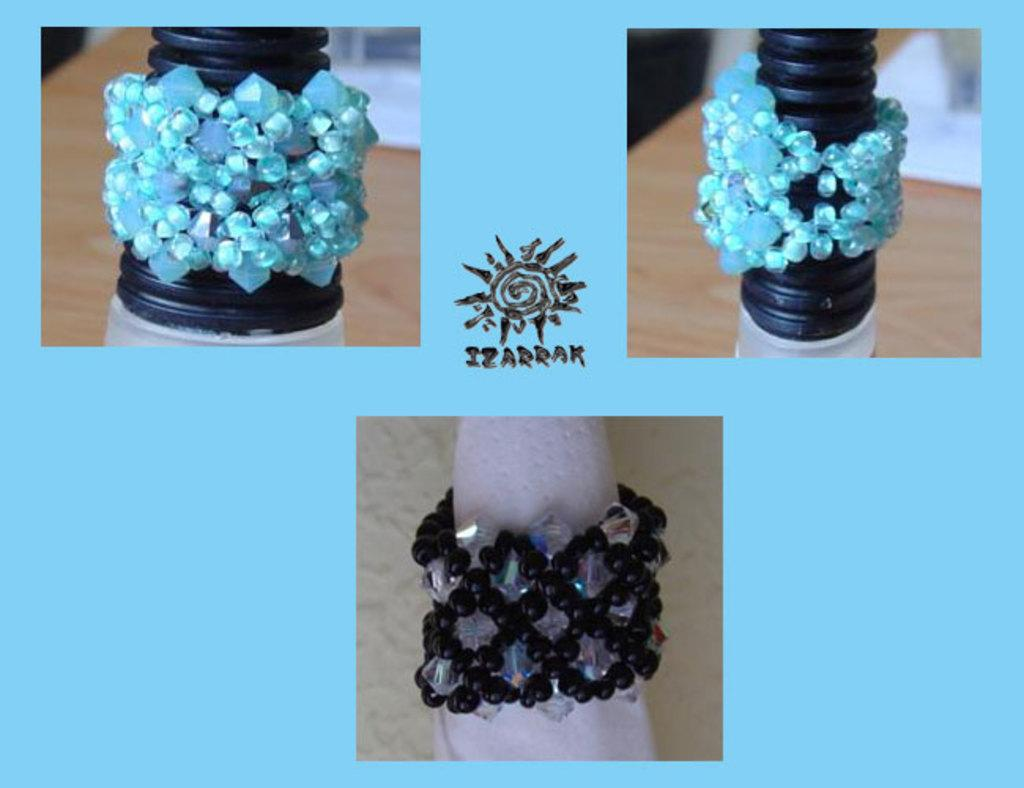What is the main subject of the three pictures in the image? The main subject of the three pictures in the image is bracelets. What color is the background of the image? The background of the image is blue. What can be found in the center of the background? There is a logo and text in the center of the background. How many bees can be seen flying around the bracelets in the image? There are no bees present in the image; it only features pictures of bracelets, a blue background, and a logo with text in the center. 